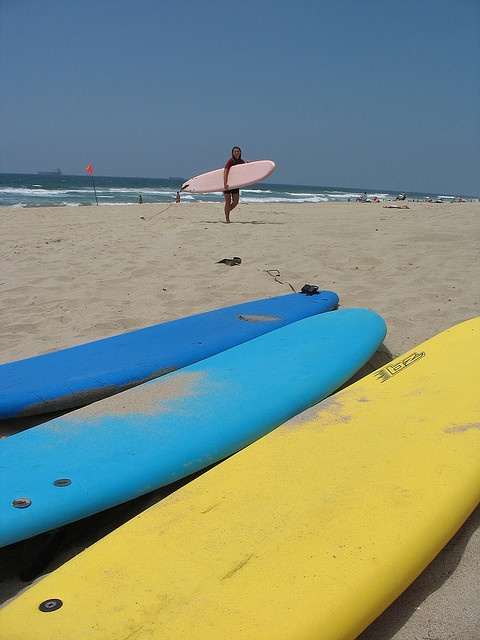Describe the objects in this image and their specific colors. I can see surfboard in gray, gold, and olive tones, surfboard in gray, lightblue, darkgray, and teal tones, surfboard in gray, darkgray, and black tones, surfboard in gray and darkgray tones, and people in gray, maroon, black, and darkgray tones in this image. 